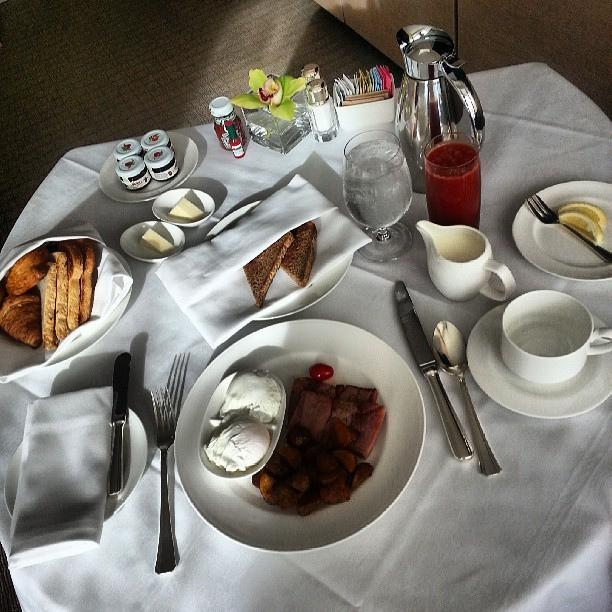When is the type of meal above favorable to be served? Please explain your reasoning. breakfast. Croiscants would suggest it is served in the morning. 